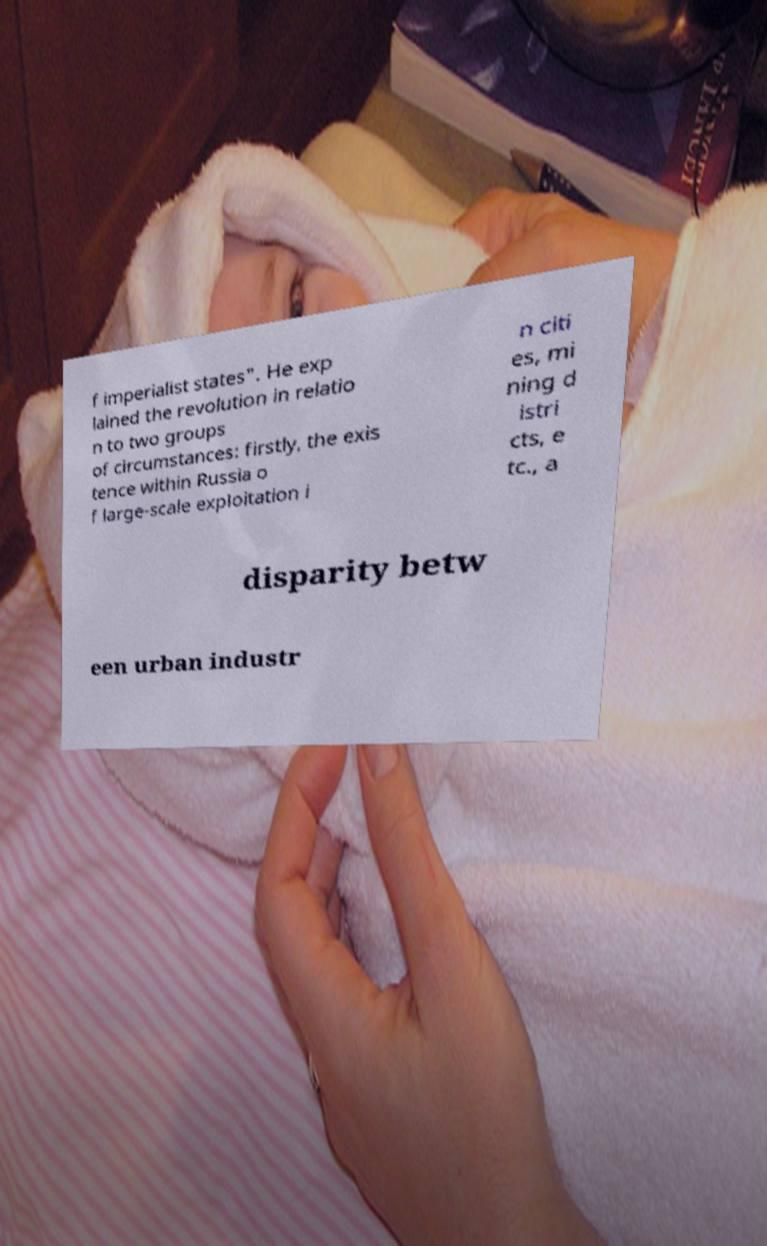Can you read and provide the text displayed in the image?This photo seems to have some interesting text. Can you extract and type it out for me? f imperialist states". He exp lained the revolution in relatio n to two groups of circumstances: firstly, the exis tence within Russia o f large-scale exploitation i n citi es, mi ning d istri cts, e tc., a disparity betw een urban industr 